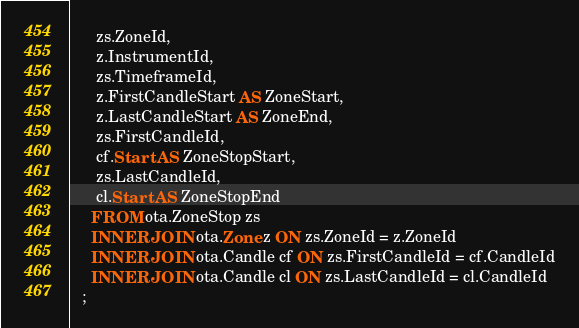Convert code to text. <code><loc_0><loc_0><loc_500><loc_500><_SQL_>      zs.ZoneId,
      z.InstrumentId,
      zs.TimeframeId,
      z.FirstCandleStart AS ZoneStart,
      z.LastCandleStart AS ZoneEnd,
      zs.FirstCandleId,
      cf.Start AS ZoneStopStart,
      zs.LastCandleId,
      cl.Start AS ZoneStopEnd
     FROM ota.ZoneStop zs
     INNER JOIN ota.Zone z ON zs.ZoneId = z.ZoneId
     INNER JOIN ota.Candle cf ON zs.FirstCandleId = cf.CandleId
     INNER JOIN ota.Candle cl ON zs.LastCandleId = cl.CandleId
   ;</code> 